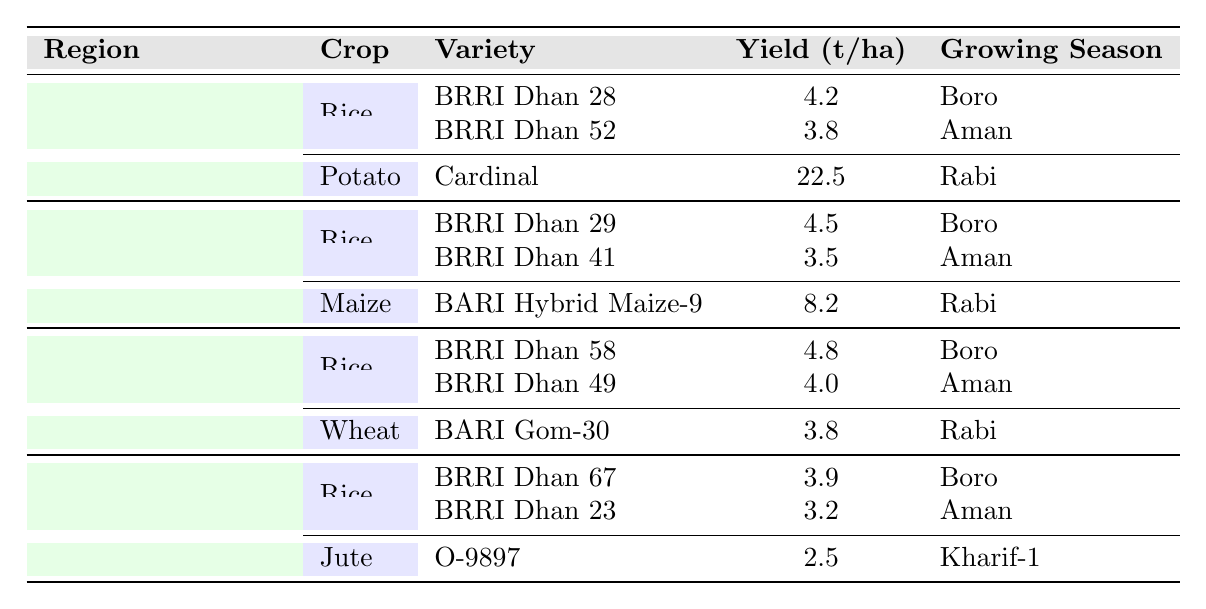What is the highest yield of rice in the Dhaka Division? In the Dhaka Division, BRRI Dhan 28 has the highest yield of 4.2 tons/hectare, compared to BRRI Dhan 52 which has a yield of 3.8 tons/hectare.
Answer: 4.2 tons/hectare What is the growing season for Cardinal potato variety in Dhaka Division? The Cardinal potato variety in the Dhaka Division is grown in the Rabi season, as indicated in the table.
Answer: Rabi Which rice variety in the Chittagong Division has the lowest yield? The rice variety with the lowest yield in the Chittagong Division is BRRI Dhan 41, which has a yield of 3.5 tons/hectare, lower than BRRI Dhan 29's yield of 4.5 tons/hectare.
Answer: BRRI Dhan 41 What is the total yield of the two rice varieties in the Rajshahi Division? For the Rajshahi Division, the total yield of rice varieties is calculated by adding the yields: 4.8 (BRRI Dhan 58) + 4.0 (BRRI Dhan 49) = 8.8 tons/hectare.
Answer: 8.8 tons/hectare Which region has the highest potato yield? The highest potato yield is found in the Dhaka Division with the Cardinal variety producing 22.5 tons/hectare, higher than any other crop's yield in the table.
Answer: Dhaka Division How many different crops are listed for the Khulna Division? The Khulna Division lists two different crops: rice and jute, thus there are 2 crops in total.
Answer: 2 crops Which crop has the highest yield in the Chittagong Division? The crop with the highest yield in the Chittagong Division is maize, particularly the BARI Hybrid Maize-9 variety which yields 8.2 tons/hectare, higher than rice varieties in the same region.
Answer: Maize What is the average yield of rice across all regions in the given table? To find the average yield of rice across regions, we add the yields: 4.2 (Dhaka) + 4.5 (Chittagong) + 4.8 (Rajshahi) + 3.9 (Khulna) = 17.4 tons/hectare. Then divide by the number of regions (4), which gives 17.4/4 = 4.35 tons/hectare.
Answer: 4.35 tons/hectare Is BRRI Dhan 58 the highest yielding rice variety in Bangladesh? No, BRRI Dhan 58 has a yield of 4.8 tons/hectare, but BRRI Dhan 29 from Chittagong Division has a higher yield of 4.5 tons/hectare.
Answer: No Which crop in the Rajshahi Division is grown in the Rabi season? The only crop listed for the Rajshahi Division that is grown in the Rabi season is wheat, specifically the BARI Gom-30 variety.
Answer: Wheat 